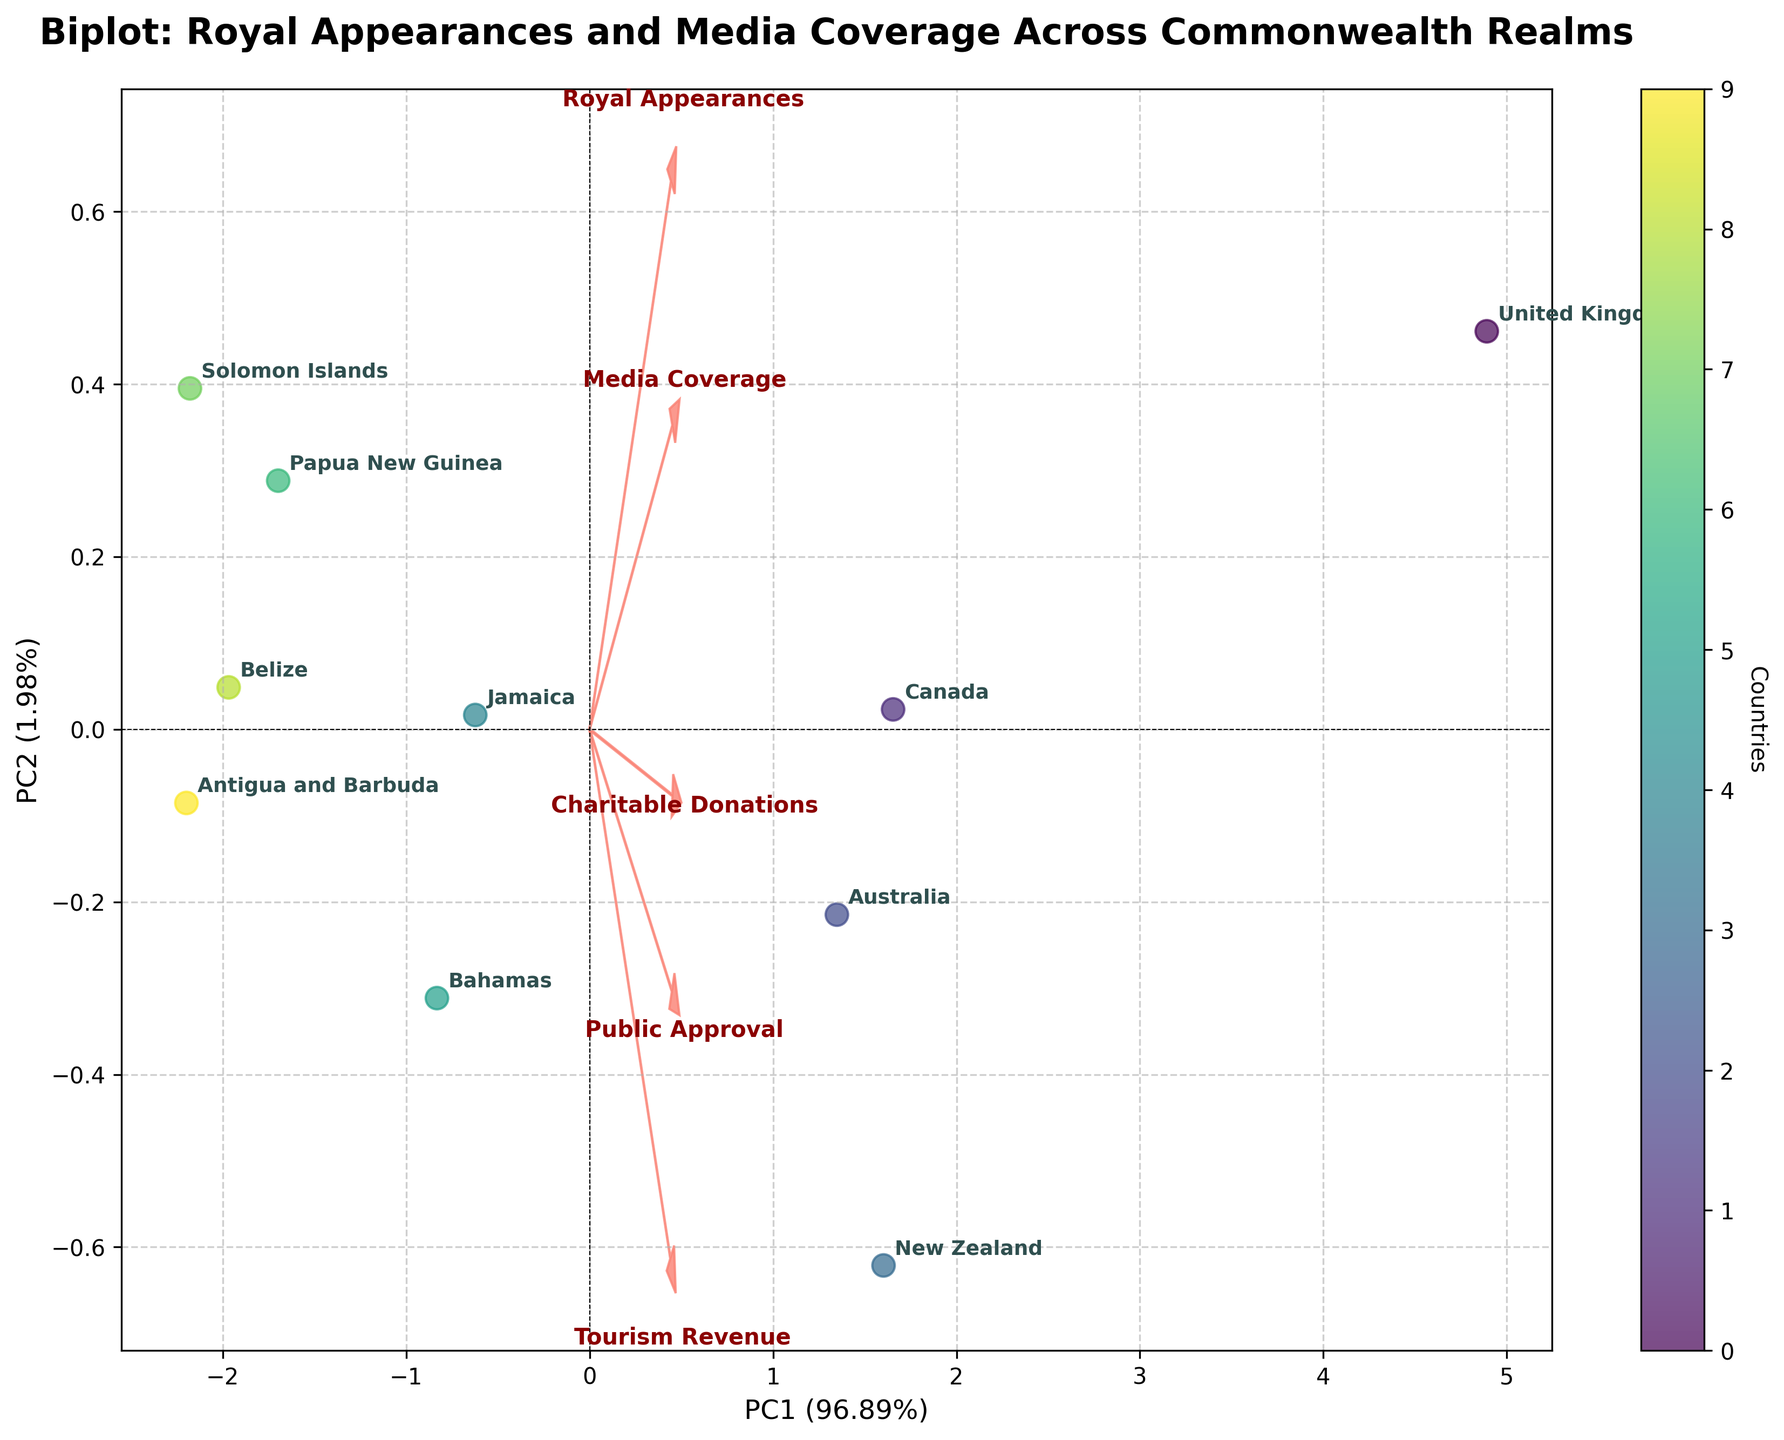What is the title of the figure? The title is usually prominently displayed at the top of a plot, often in larger or bold font. Here, the title is located at the top-center of the plot.
Answer: Biplot: Royal Appearances and Media Coverage Across Commonwealth Realms How many countries are represented in the plot? The number of countries can be determined by counting the labeled data points on the plot.
Answer: 10 Which country had the highest frequency of royal appearances? Identify the data point furthest to the right on the x-axis, which likely represents the highest number of royal appearances. According to the labels, it corresponds to the United Kingdom.
Answer: United Kingdom Does any country appear to have low values in both royal appearances and media coverage? If so, which one? Look for the data point near the bottom-left of the plot, which represents low values on both axes. This point corresponds to Antigua and Barbuda.
Answer: Antigua and Barbuda Which feature vector points most strongly towards the first principal component (PC1)? Feature vectors are represented by arrows. Identify the arrow that extends furthest along the x-axis direction (PC1). The longest arrow corresponds to 'Royal Appearances.'
Answer: Royal Appearances What relationship do the feature vectors suggest between royal appearances and tourism revenue? Observing the direction and length of the arrows labeled 'Royal Appearances' and 'Tourism Revenue,' if they point in similar directions, it suggests a positive relationship.
Answer: Positive relationship How much of the total variance is explained by the first principal component (PC1)? The percentage explained by PC1 is usually mentioned in the label of the x-axis.
Answer: The exact percentage can be derived from the axis label of PC1, e.g., 53.71% Which two countries are closest together on the plot? Find the pair of labeled data points that are nearest to each other in the plot.
Answer: New Zealand and Australia Compare the media coverage of the United Kingdom and Canada. By noting the position of the labeled data points, the United Kingdom is positioned higher on the y-axis compared to Canada, indicating higher media coverage.
Answer: United Kingdom has higher media coverage than Canada What does the color gradient in the plot represent? A color gradient usually indicates a continuous variable or category differentiation. Here, it represents the different countries, with each country corresponding to a unique color.
Answer: Different countries 